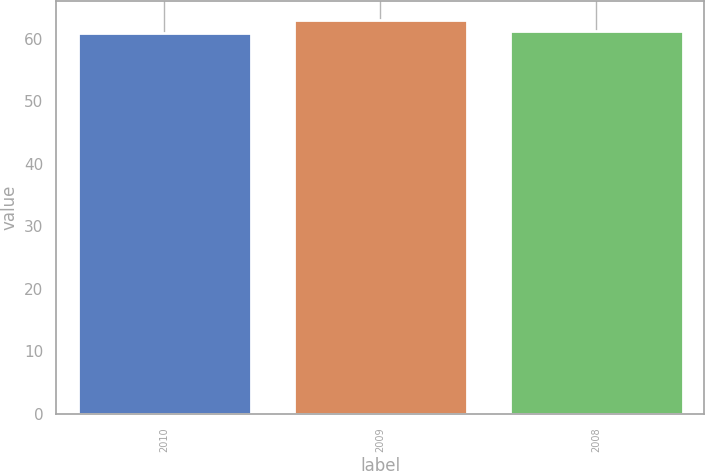<chart> <loc_0><loc_0><loc_500><loc_500><bar_chart><fcel>2010<fcel>2009<fcel>2008<nl><fcel>61<fcel>63<fcel>61.2<nl></chart> 